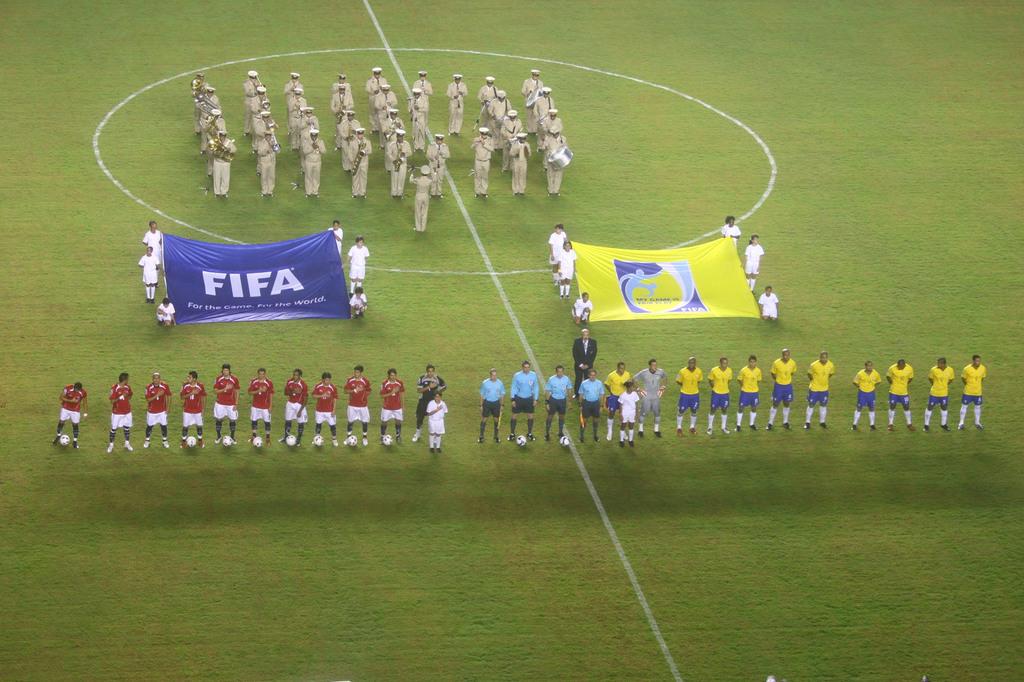What i the first word under fifa on the blue banner?
Provide a succinct answer. For. What brand is on the blue flad?
Provide a short and direct response. Fifa. 